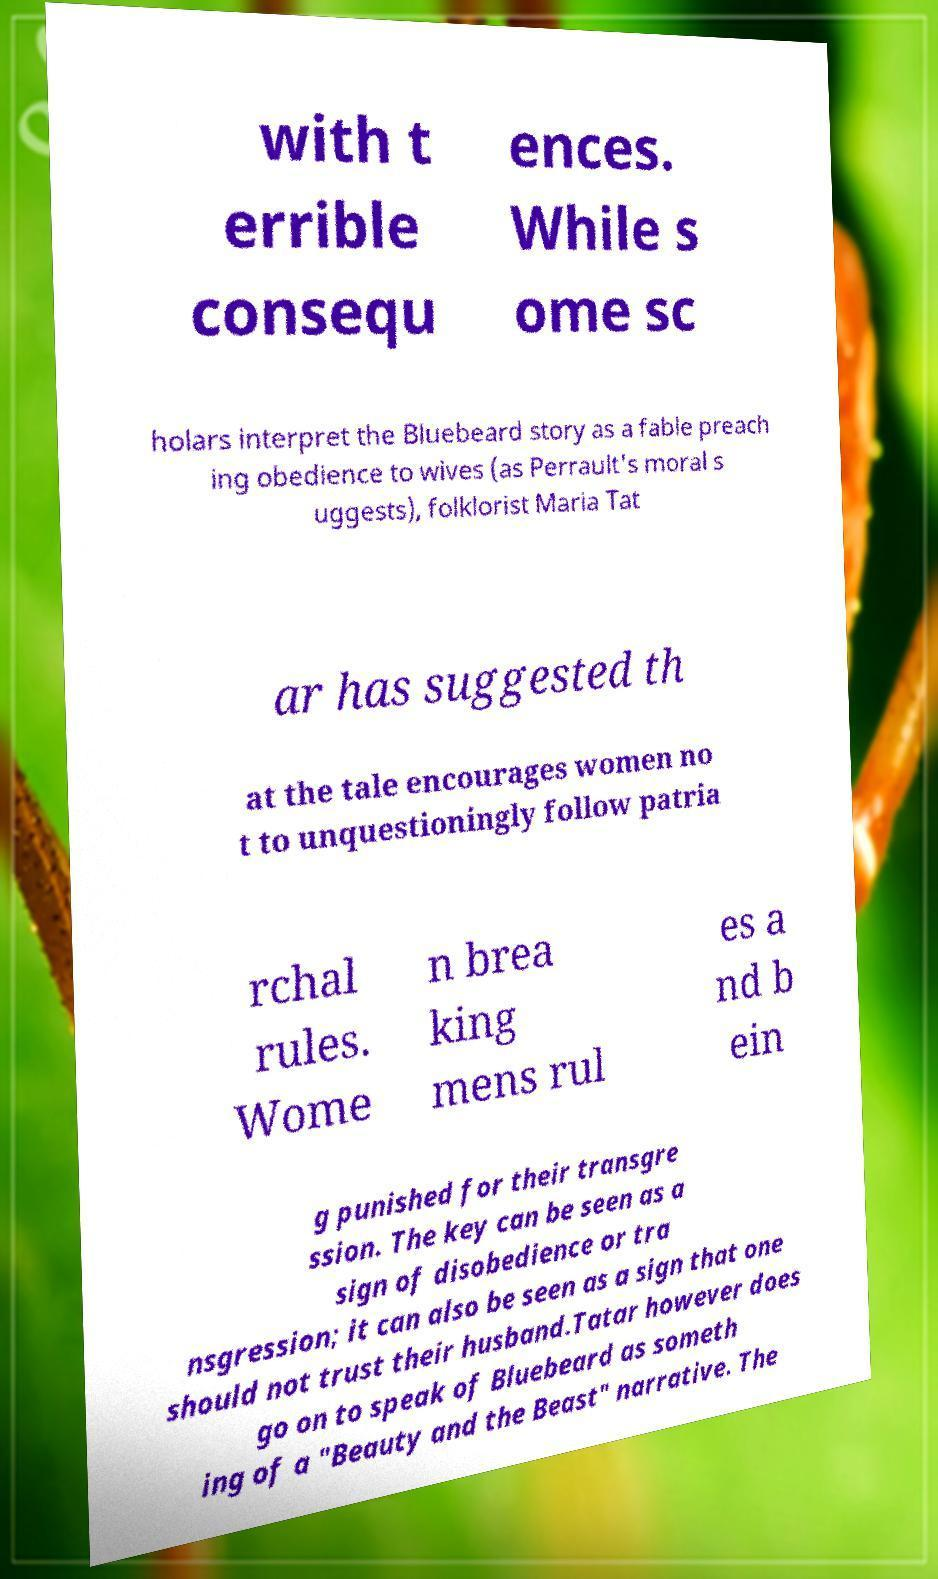There's text embedded in this image that I need extracted. Can you transcribe it verbatim? with t errible consequ ences. While s ome sc holars interpret the Bluebeard story as a fable preach ing obedience to wives (as Perrault's moral s uggests), folklorist Maria Tat ar has suggested th at the tale encourages women no t to unquestioningly follow patria rchal rules. Wome n brea king mens rul es a nd b ein g punished for their transgre ssion. The key can be seen as a sign of disobedience or tra nsgression; it can also be seen as a sign that one should not trust their husband.Tatar however does go on to speak of Bluebeard as someth ing of a "Beauty and the Beast" narrative. The 